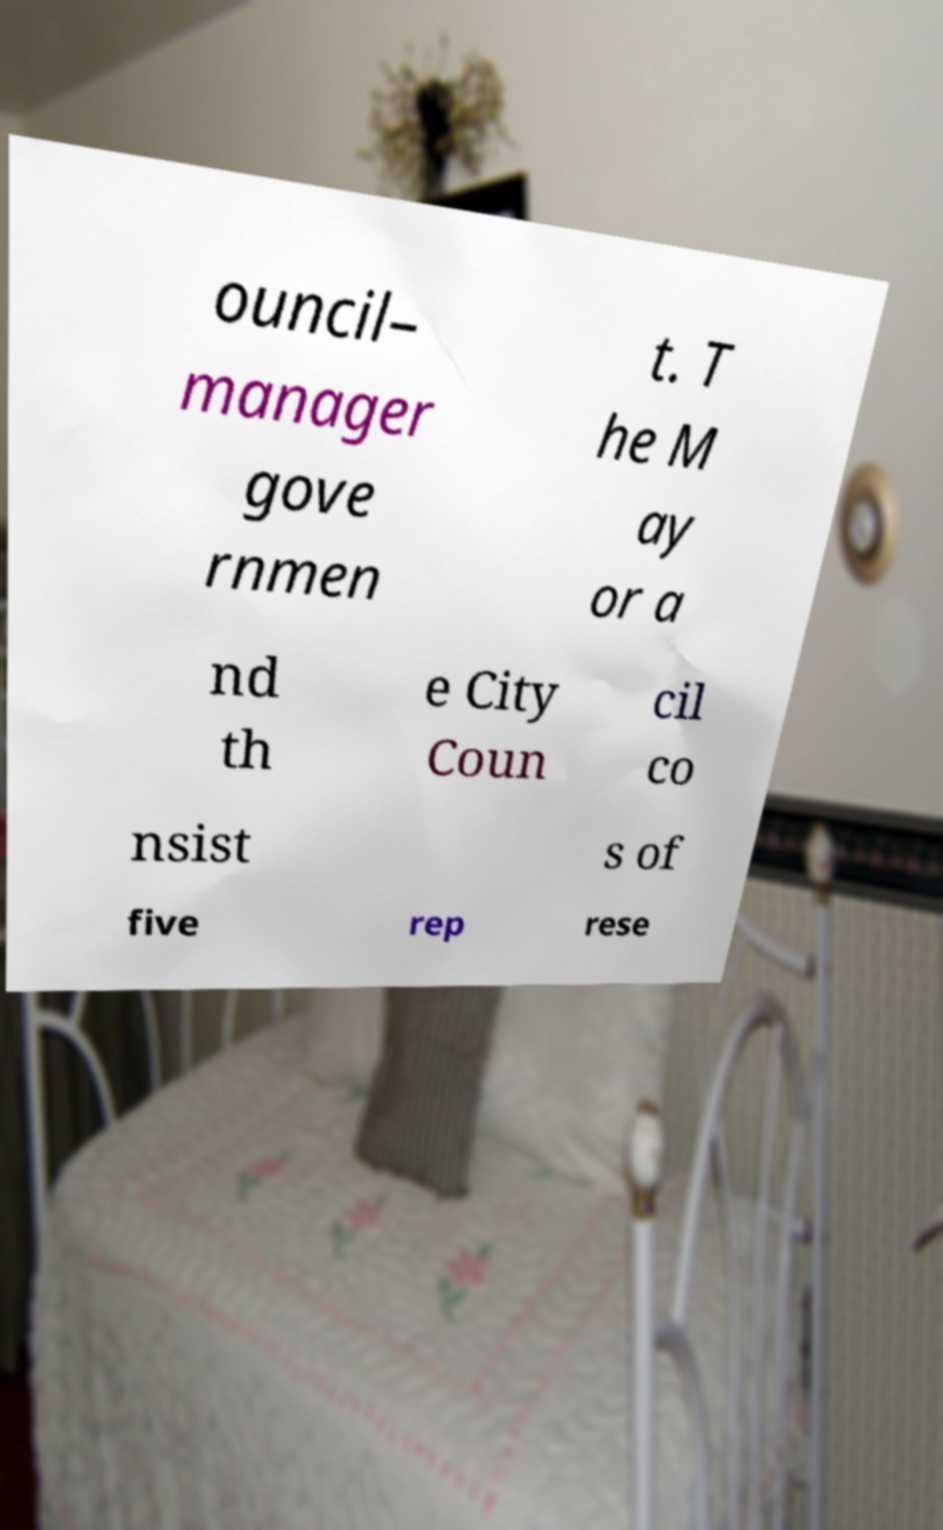What messages or text are displayed in this image? I need them in a readable, typed format. ouncil– manager gove rnmen t. T he M ay or a nd th e City Coun cil co nsist s of five rep rese 